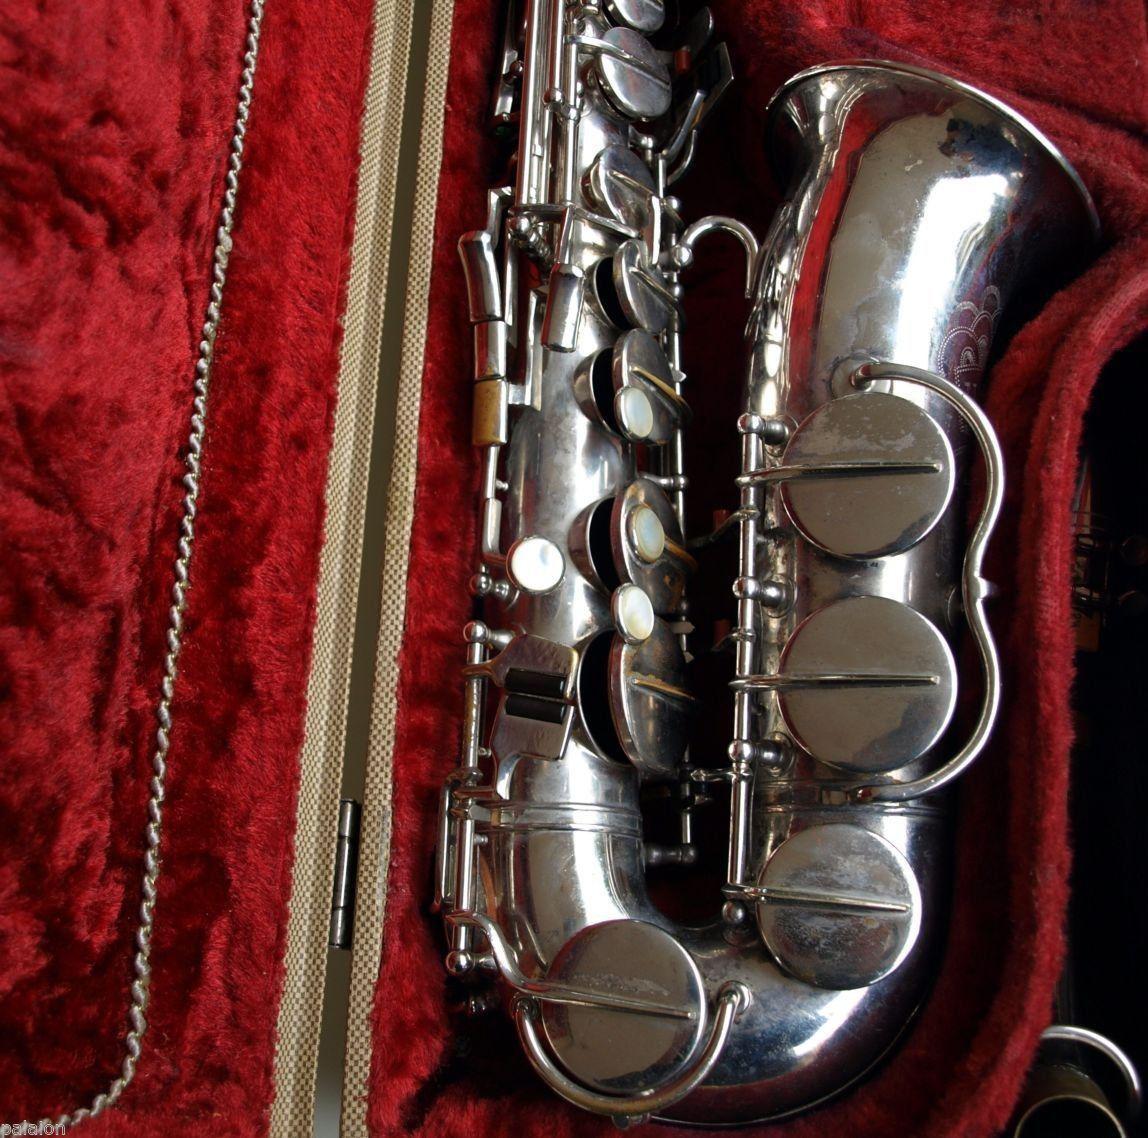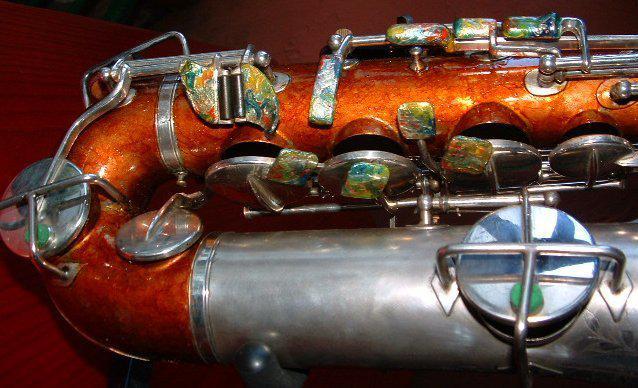The first image is the image on the left, the second image is the image on the right. For the images displayed, is the sentence "The left sax is gold and the right one is silver." factually correct? Answer yes or no. No. The first image is the image on the left, the second image is the image on the right. For the images displayed, is the sentence "A total of two saxophones are shown, and one saxophone is displayed on some type of red fabric." factually correct? Answer yes or no. Yes. 